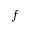<formula> <loc_0><loc_0><loc_500><loc_500>f</formula> 